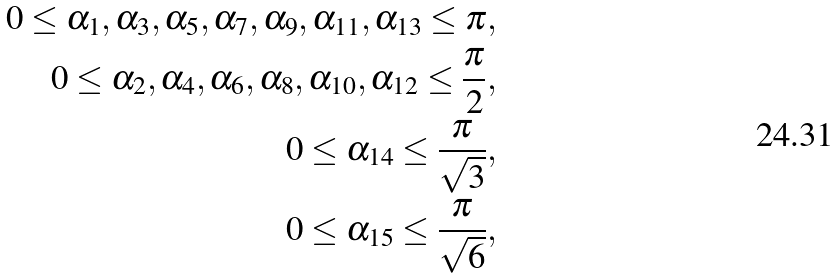Convert formula to latex. <formula><loc_0><loc_0><loc_500><loc_500>0 \leq \alpha _ { 1 } , \alpha _ { 3 } , \alpha _ { 5 } , \alpha _ { 7 } , \alpha _ { 9 } , \alpha _ { 1 1 } , \alpha _ { 1 3 } \leq \pi , \\ 0 \leq \alpha _ { 2 } , \alpha _ { 4 } , \alpha _ { 6 } , \alpha _ { 8 } , \alpha _ { 1 0 } , \alpha _ { 1 2 } \leq \frac { \pi } { 2 } , \\ 0 \leq \alpha _ { 1 4 } \leq \frac { \pi } { \sqrt { 3 } } , \\ 0 \leq \alpha _ { 1 5 } \leq \frac { \pi } { \sqrt { 6 } } ,</formula> 